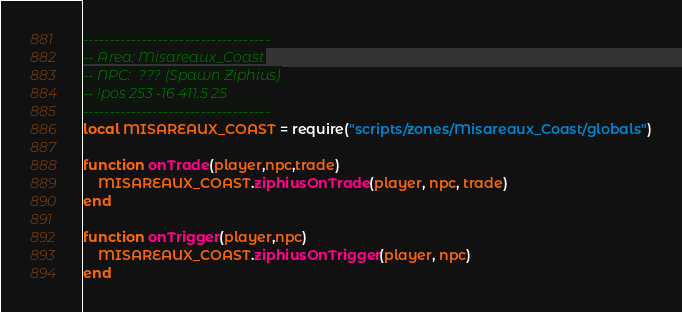Convert code to text. <code><loc_0><loc_0><loc_500><loc_500><_Lua_>-----------------------------------
-- Area: Misareaux_Coast
-- NPC:  ??? (Spawn Ziphius)
-- !pos 253 -16 411.5 25
-----------------------------------
local MISAREAUX_COAST = require("scripts/zones/Misareaux_Coast/globals")

function onTrade(player,npc,trade)
    MISAREAUX_COAST.ziphiusOnTrade(player, npc, trade)
end

function onTrigger(player,npc)
    MISAREAUX_COAST.ziphiusOnTrigger(player, npc)
end</code> 